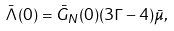<formula> <loc_0><loc_0><loc_500><loc_500>\bar { \Lambda } ( 0 ) = \bar { G } _ { N } ( 0 ) ( 3 \Gamma - 4 ) \bar { \mu } ,</formula> 